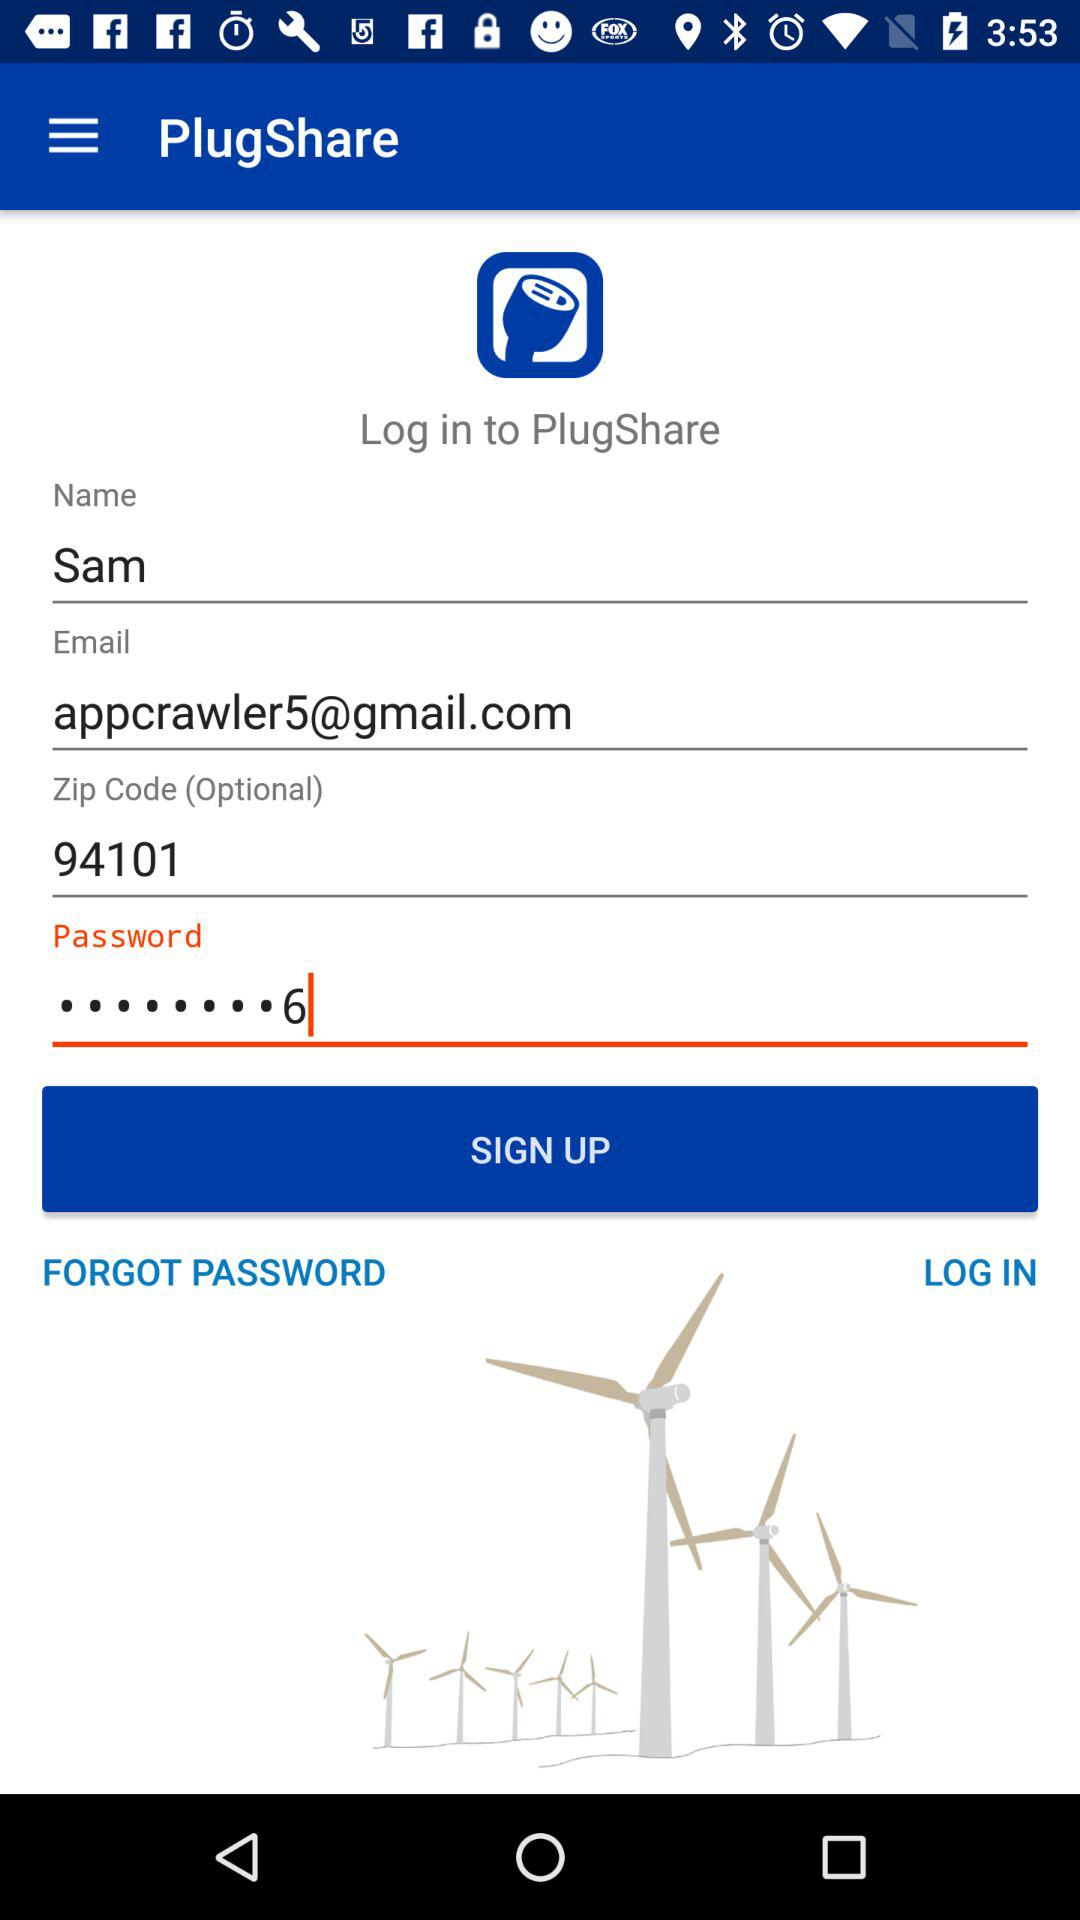What is the name? The name is Sam. 